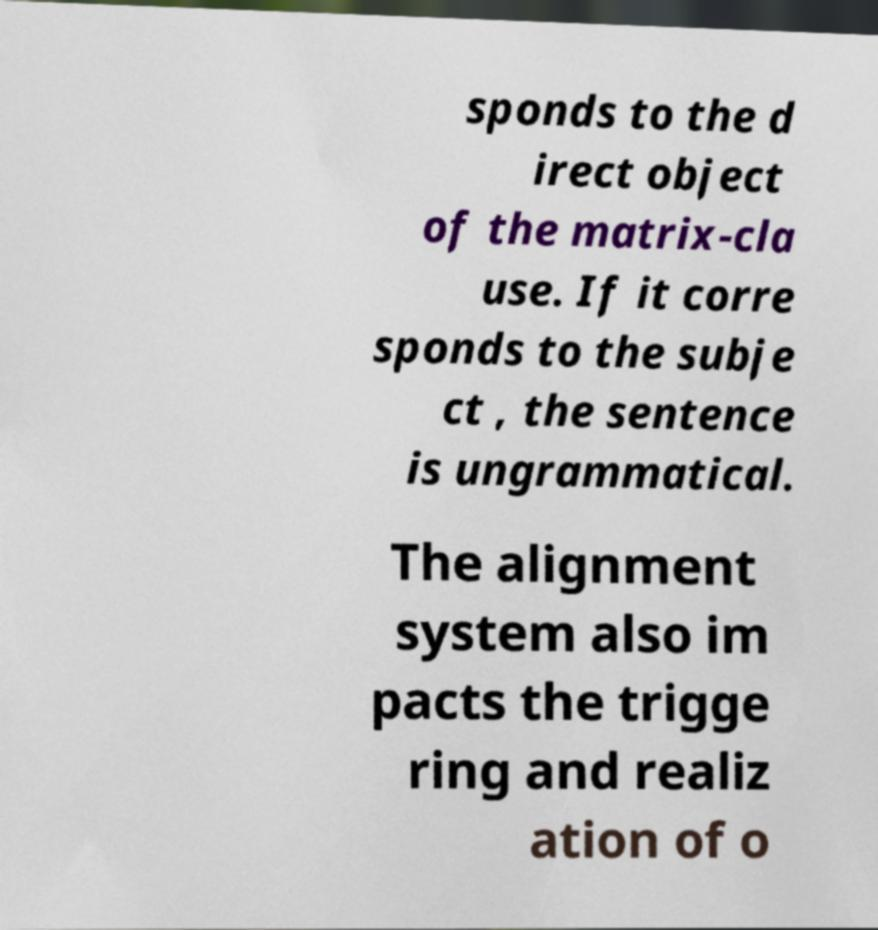Could you extract and type out the text from this image? sponds to the d irect object of the matrix-cla use. If it corre sponds to the subje ct , the sentence is ungrammatical. The alignment system also im pacts the trigge ring and realiz ation of o 